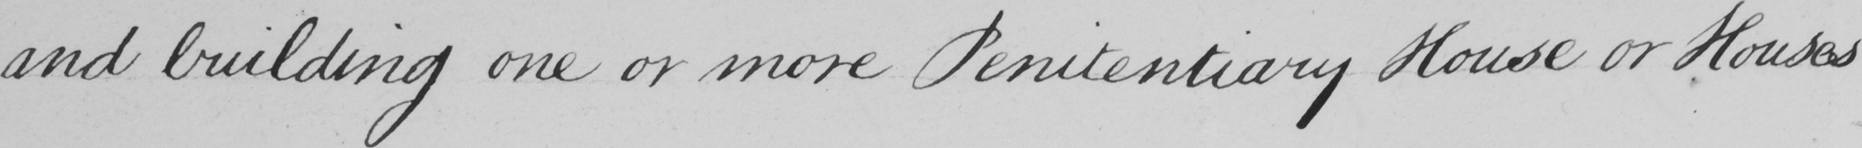Can you read and transcribe this handwriting? and building one or more Penitentiary House or Houses 